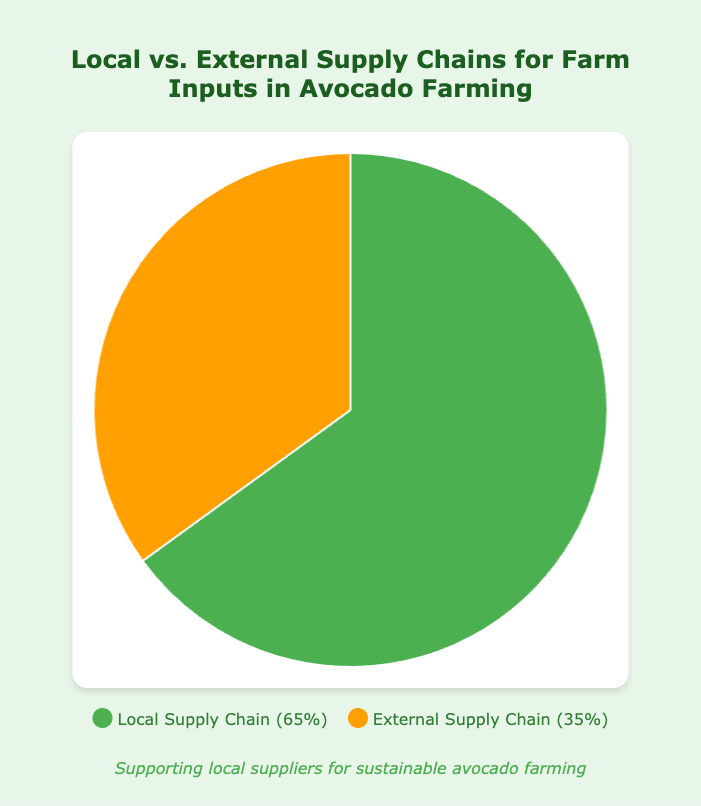What percentage of farm inputs are sourced locally? The chart shows that the local supply chain accounts for 65% of the farm inputs.
Answer: 65% How much higher is the percentage of local supply chain inputs compared to external supply chain inputs? The percentage of local supply chain inputs (65%) is 30% higher than the percentage of external supply chain inputs (35%).
Answer: 30% Which supply chain is represented by the color green? According to the legend, the local supply chain is represented by the color green.
Answer: Local supply chain Add the contributions of Local Fertilizer Suppliers and Local Compost Suppliers. What is the total? Local Fertilizer Suppliers contribute 35% and Local Compost Suppliers contribute 30%. Adding these gives 35% + 30% = 65%.
Answer: 65% Compare the contribution of Local Irrigation Equipment Vendors to External Irrigation Equipment in terms of percentage. Which is higher and by how much? Local Irrigation Equipment Vendors contribute 20%, while External Irrigation Equipment contributes 40%. The external contribution is higher by 20%.
Answer: External by 20% Considering both supply chains, what is the total contribution of all fertilizer suppliers? Local Fertilizer Suppliers contribute 35% and Imported Fertilizer contributes 20%. The total contribution is 35%+20% = 55%.
Answer: 55% How much does Imported Pest Control contribute compared to Local Pest Control? Imported Pest Control contributes 30%, while Local Pest Control contributes 15%. Imported Pest Control contributes 15% more.
Answer: 15% more If Local and External Supply Chains each contribute exactly 100%, what would be the overall percentage for Local Supply contributions excluding Local Fertilizer Suppliers? Local Supply Chain contributes 65%, Local Fertilizer Suppliers contribute 35%, so the percentage for other local supplies is 65% - 35% = 30%.
Answer: 30% Which supplier has the largest individual contribution among all suppliers? External Irrigation Equipment contributes 40%, which is the highest individual contribution.
Answer: External Irrigation Equipment What color represents the external supply chain, and what does the percentage indicate? The external supply chain color is orange and it indicates 35%.
Answer: Orange, 35% 